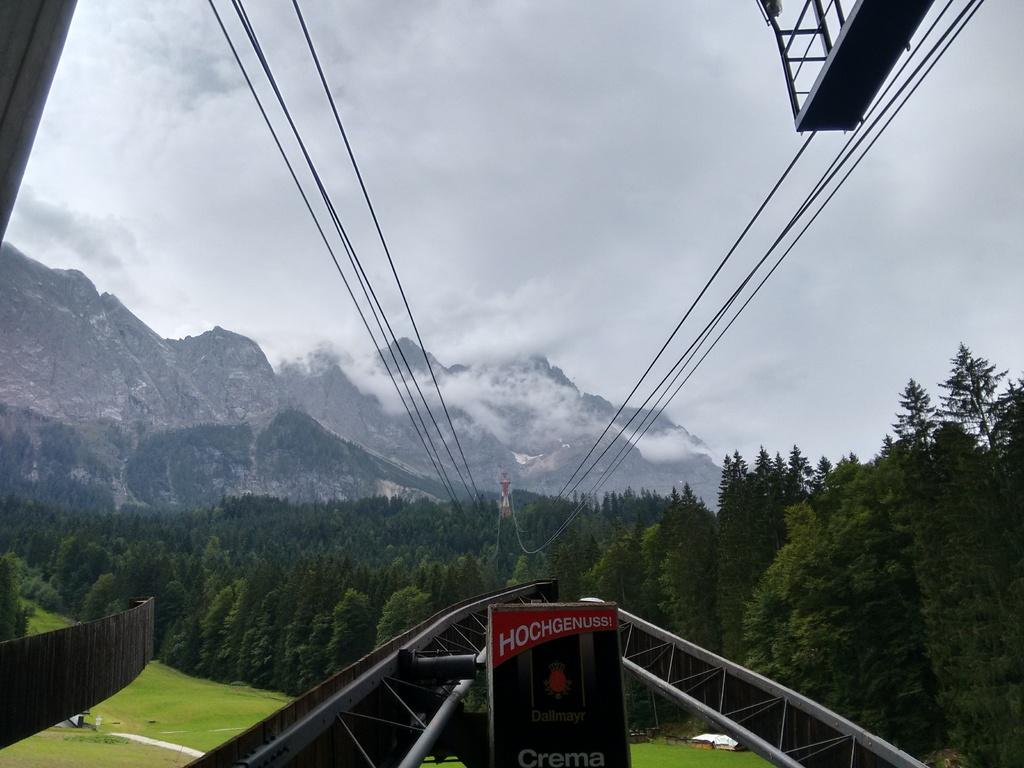What is the main object in the picture? There is a board in the picture. What type of transportation is visible in the picture? There is a ropeway in the picture. What type of landscape is shown in the picture? There are grasslands, trees, and mountains in the picture. What is the weather like in the background of the picture? The sky is cloudy, and there is fog in the background of the picture. How many beggars can be seen in the picture? There are no beggars present in the picture. What type of calculator is being used by the cat in the picture? There is no cat or calculator present in the picture. 